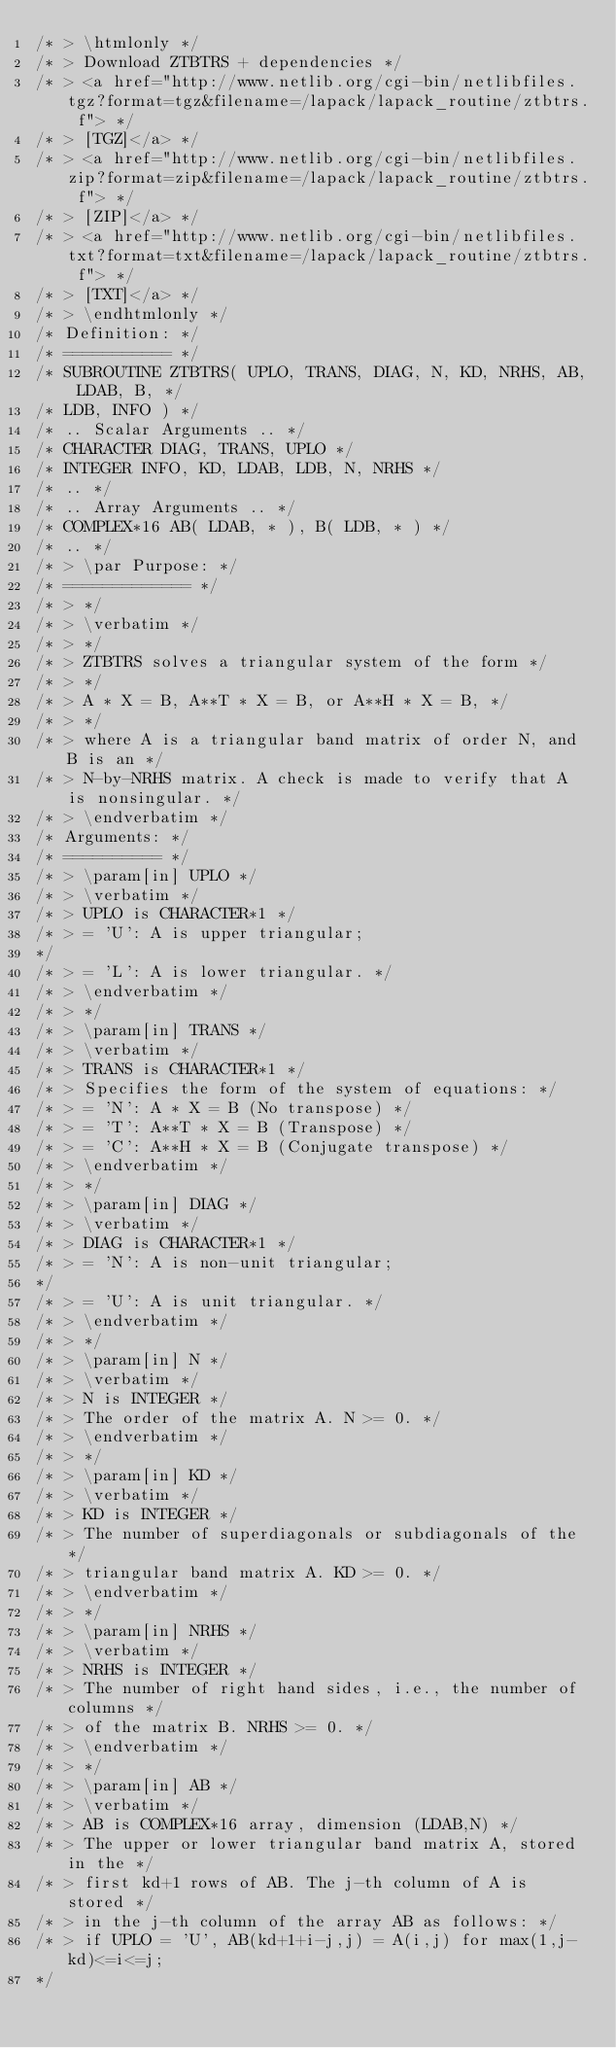Convert code to text. <code><loc_0><loc_0><loc_500><loc_500><_C_>/* > \htmlonly */
/* > Download ZTBTRS + dependencies */
/* > <a href="http://www.netlib.org/cgi-bin/netlibfiles.tgz?format=tgz&filename=/lapack/lapack_routine/ztbtrs. f"> */
/* > [TGZ]</a> */
/* > <a href="http://www.netlib.org/cgi-bin/netlibfiles.zip?format=zip&filename=/lapack/lapack_routine/ztbtrs. f"> */
/* > [ZIP]</a> */
/* > <a href="http://www.netlib.org/cgi-bin/netlibfiles.txt?format=txt&filename=/lapack/lapack_routine/ztbtrs. f"> */
/* > [TXT]</a> */
/* > \endhtmlonly */
/* Definition: */
/* =========== */
/* SUBROUTINE ZTBTRS( UPLO, TRANS, DIAG, N, KD, NRHS, AB, LDAB, B, */
/* LDB, INFO ) */
/* .. Scalar Arguments .. */
/* CHARACTER DIAG, TRANS, UPLO */
/* INTEGER INFO, KD, LDAB, LDB, N, NRHS */
/* .. */
/* .. Array Arguments .. */
/* COMPLEX*16 AB( LDAB, * ), B( LDB, * ) */
/* .. */
/* > \par Purpose: */
/* ============= */
/* > */
/* > \verbatim */
/* > */
/* > ZTBTRS solves a triangular system of the form */
/* > */
/* > A * X = B, A**T * X = B, or A**H * X = B, */
/* > */
/* > where A is a triangular band matrix of order N, and B is an */
/* > N-by-NRHS matrix. A check is made to verify that A is nonsingular. */
/* > \endverbatim */
/* Arguments: */
/* ========== */
/* > \param[in] UPLO */
/* > \verbatim */
/* > UPLO is CHARACTER*1 */
/* > = 'U': A is upper triangular;
*/
/* > = 'L': A is lower triangular. */
/* > \endverbatim */
/* > */
/* > \param[in] TRANS */
/* > \verbatim */
/* > TRANS is CHARACTER*1 */
/* > Specifies the form of the system of equations: */
/* > = 'N': A * X = B (No transpose) */
/* > = 'T': A**T * X = B (Transpose) */
/* > = 'C': A**H * X = B (Conjugate transpose) */
/* > \endverbatim */
/* > */
/* > \param[in] DIAG */
/* > \verbatim */
/* > DIAG is CHARACTER*1 */
/* > = 'N': A is non-unit triangular;
*/
/* > = 'U': A is unit triangular. */
/* > \endverbatim */
/* > */
/* > \param[in] N */
/* > \verbatim */
/* > N is INTEGER */
/* > The order of the matrix A. N >= 0. */
/* > \endverbatim */
/* > */
/* > \param[in] KD */
/* > \verbatim */
/* > KD is INTEGER */
/* > The number of superdiagonals or subdiagonals of the */
/* > triangular band matrix A. KD >= 0. */
/* > \endverbatim */
/* > */
/* > \param[in] NRHS */
/* > \verbatim */
/* > NRHS is INTEGER */
/* > The number of right hand sides, i.e., the number of columns */
/* > of the matrix B. NRHS >= 0. */
/* > \endverbatim */
/* > */
/* > \param[in] AB */
/* > \verbatim */
/* > AB is COMPLEX*16 array, dimension (LDAB,N) */
/* > The upper or lower triangular band matrix A, stored in the */
/* > first kd+1 rows of AB. The j-th column of A is stored */
/* > in the j-th column of the array AB as follows: */
/* > if UPLO = 'U', AB(kd+1+i-j,j) = A(i,j) for max(1,j-kd)<=i<=j;
*/</code> 